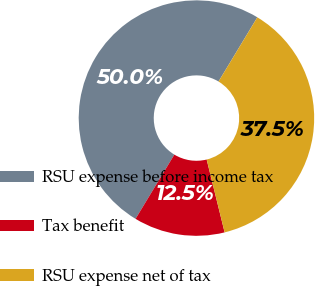<chart> <loc_0><loc_0><loc_500><loc_500><pie_chart><fcel>RSU expense before income tax<fcel>Tax benefit<fcel>RSU expense net of tax<nl><fcel>50.0%<fcel>12.5%<fcel>37.5%<nl></chart> 